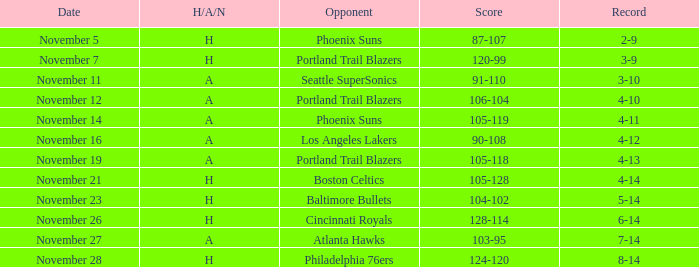On what Date was the Score 106-104 against the Portland Trail Blazers? November 12. 